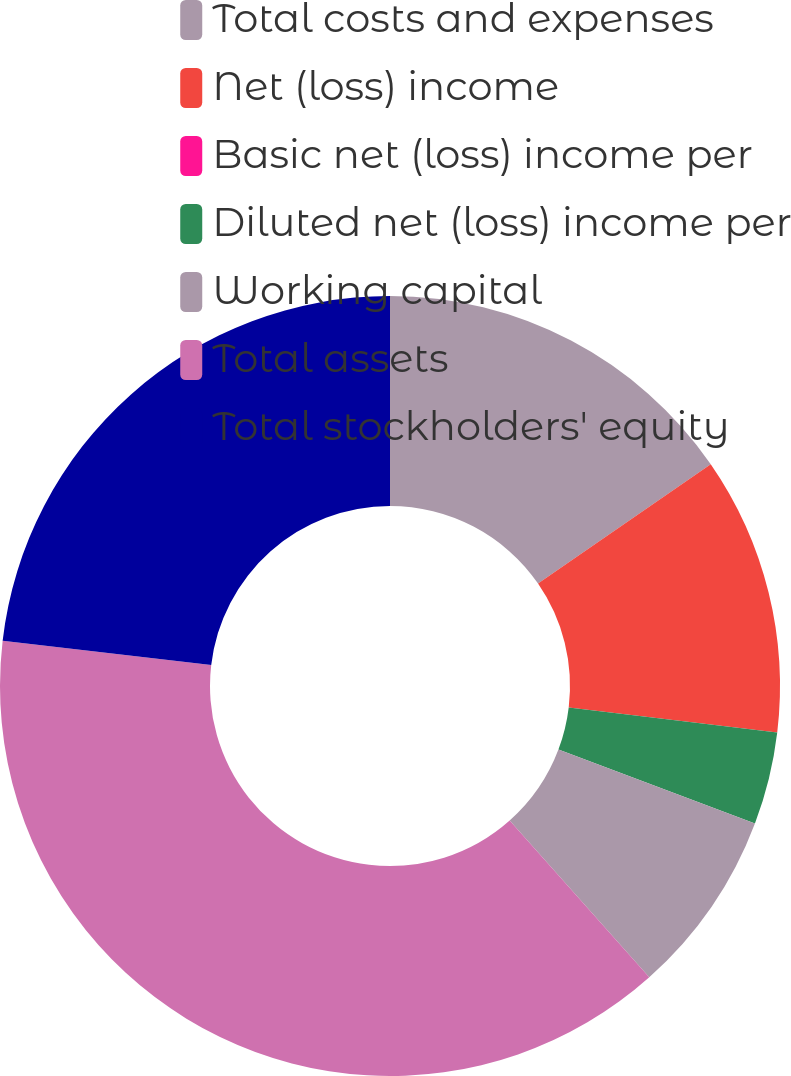Convert chart to OTSL. <chart><loc_0><loc_0><loc_500><loc_500><pie_chart><fcel>Total costs and expenses<fcel>Net (loss) income<fcel>Basic net (loss) income per<fcel>Diluted net (loss) income per<fcel>Working capital<fcel>Total assets<fcel>Total stockholders' equity<nl><fcel>15.37%<fcel>11.53%<fcel>0.0%<fcel>3.84%<fcel>7.69%<fcel>38.43%<fcel>23.15%<nl></chart> 